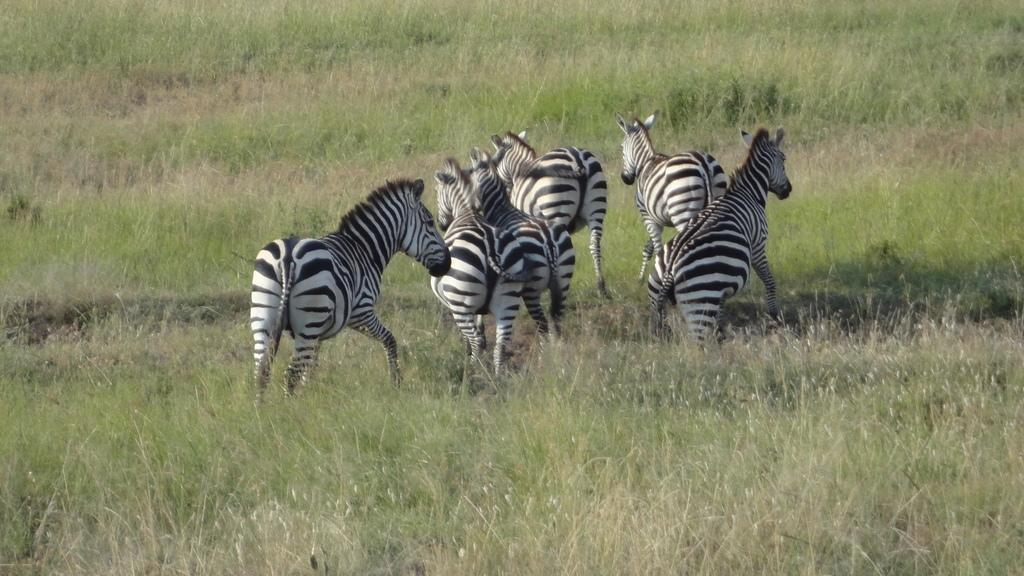What animals are in the center of the image? There are zebras in the center of the image. What type of vegetation can be seen in the image? There is grass visible in the image. What type of caption is present on the zebras' hooves in the image? There is no caption present on the zebras' hooves in the image. What type of iron object can be seen in the image? There is no iron object present in the image. 